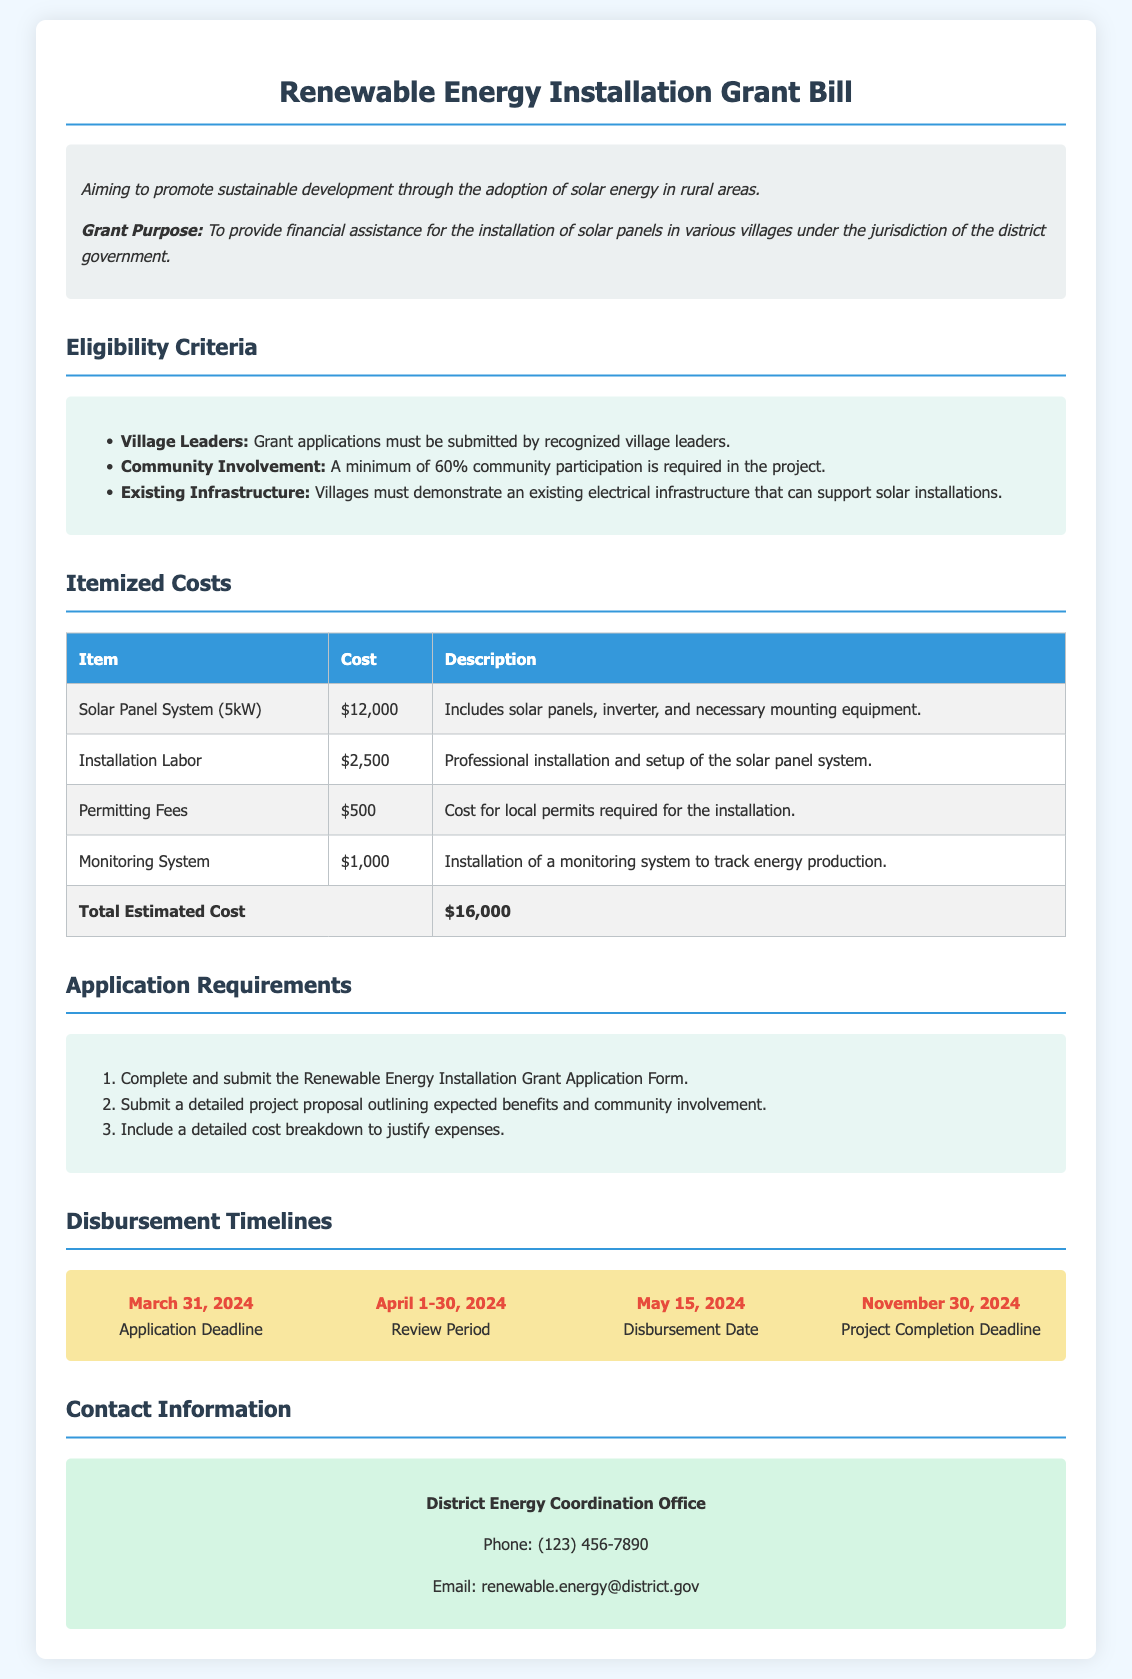What is the total estimated cost for the solar panel installation? The total estimated cost is listed at the bottom of the itemized costs section.
Answer: $16,000 Who must submit the grant applications? The eligibility section mentions that recognized village leaders are the ones who must submit grant applications.
Answer: Village Leaders What is the application deadline? The disbursement timelines provide a specific date for the application deadline.
Answer: March 31, 2024 How much is allocated for installation labor? The itemized costs table specifies the amount allocated for installation labor.
Answer: $2,500 What minimum community participation percentage is required? The eligibility criteria outline the requirement for community involvement as a percentage.
Answer: 60% What is included in the solar panel system cost? The itemized costs section describes what is included in the solar panel system.
Answer: Solar panels, inverter, and necessary mounting equipment When is the project completion deadline? The disbursement timelines section specifies the deadline for project completion.
Answer: November 30, 2024 What are the first two application requirements? The application requirements section lists the steps needed to apply for the grant.
Answer: Complete the application form and submit a detailed project proposal What is the phone number for the District Energy Coordination Office? The contact information provides the phone number for the relevant office.
Answer: (123) 456-7890 